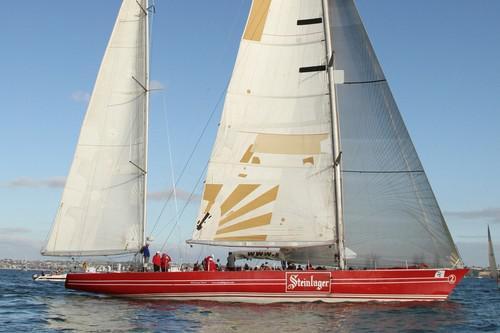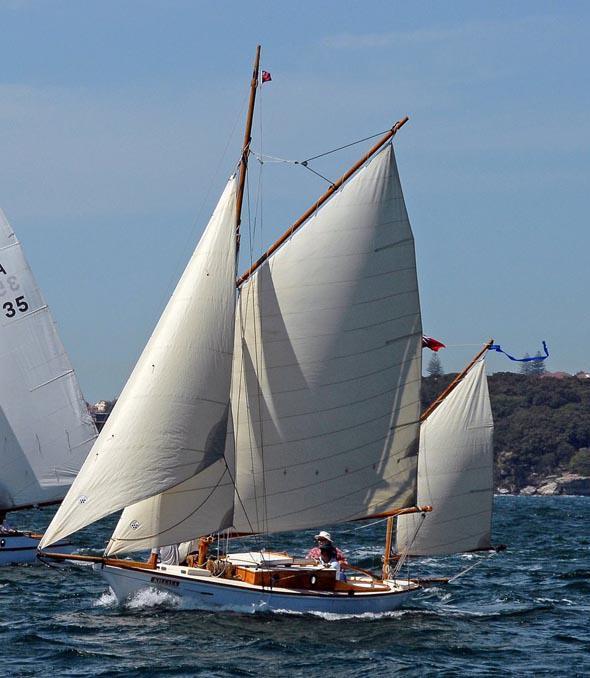The first image is the image on the left, the second image is the image on the right. Assess this claim about the two images: "All of the sails on the boat in the image to the right happen to be red.". Correct or not? Answer yes or no. No. The first image is the image on the left, the second image is the image on the right. Given the left and right images, does the statement "in the right pic the nearest pic has three sails" hold true? Answer yes or no. No. 